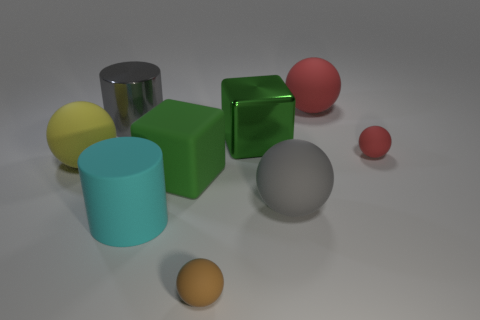How many gray metallic objects have the same shape as the small brown matte thing?
Provide a short and direct response. 0. How many large matte spheres are there?
Your answer should be very brief. 3. Do the red rubber thing that is on the left side of the tiny red object and the cyan rubber thing have the same shape?
Your answer should be compact. No. What material is the red object that is the same size as the brown rubber ball?
Provide a short and direct response. Rubber. Is there a red object that has the same material as the big gray ball?
Offer a very short reply. Yes. There is a cyan matte thing; is it the same shape as the large rubber thing to the left of the big cyan rubber thing?
Ensure brevity in your answer.  No. How many objects are both to the left of the large green metal object and behind the large gray metal cylinder?
Your answer should be compact. 0. Is the gray ball made of the same material as the large green thing that is behind the small red thing?
Offer a very short reply. No. Are there an equal number of yellow matte balls that are to the left of the yellow rubber thing and large gray matte things?
Offer a terse response. No. What color is the cylinder behind the cyan cylinder?
Give a very brief answer. Gray. 